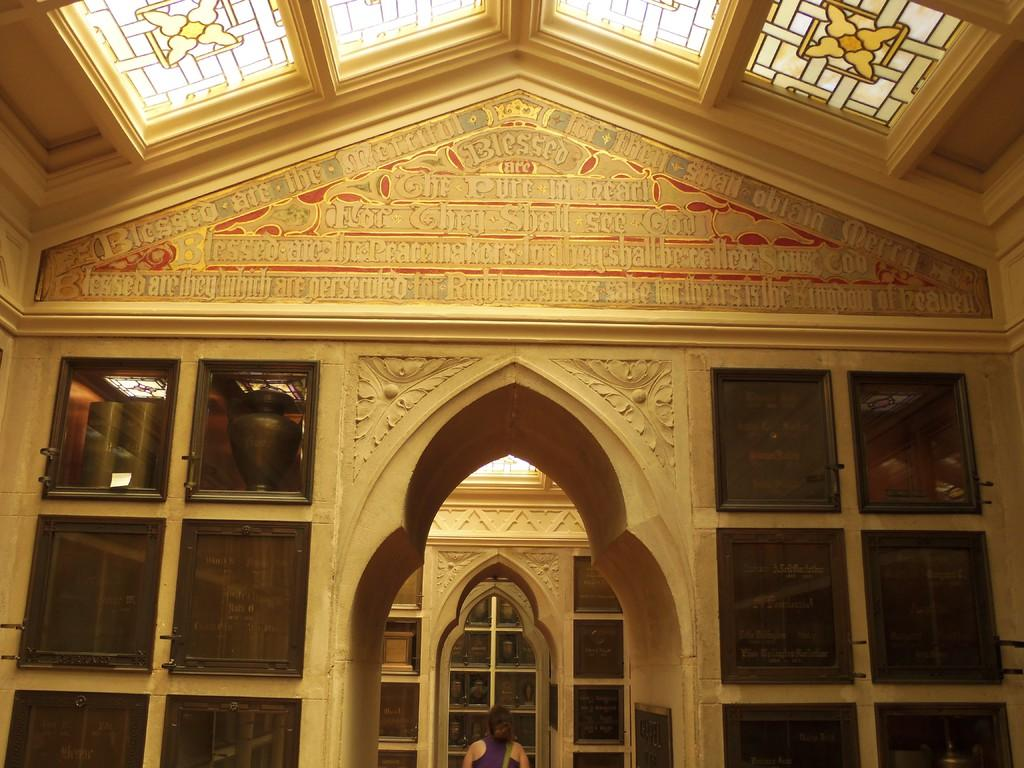What is a prominent feature in the image? There is a wall in the image. What can be found on the wall? The wall has text on it. What type of windows are present in the image? There are glass windows in the image. Can you describe the person in the image? There is a person standing in the image. What material is used for the ceiling in the image? The ceiling is made of glass. Where is the shelf located in the image? There is no shelf present in the image. Can you describe the kitty's ear in the image? There is no kitty present in the image, so its ear cannot be described. 